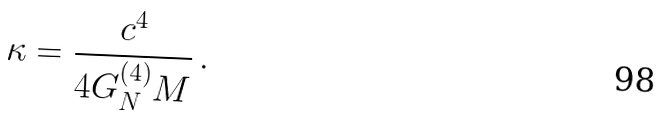Convert formula to latex. <formula><loc_0><loc_0><loc_500><loc_500>\kappa = \frac { c ^ { 4 } } { 4 G _ { N } ^ { ( 4 ) } M } \, .</formula> 